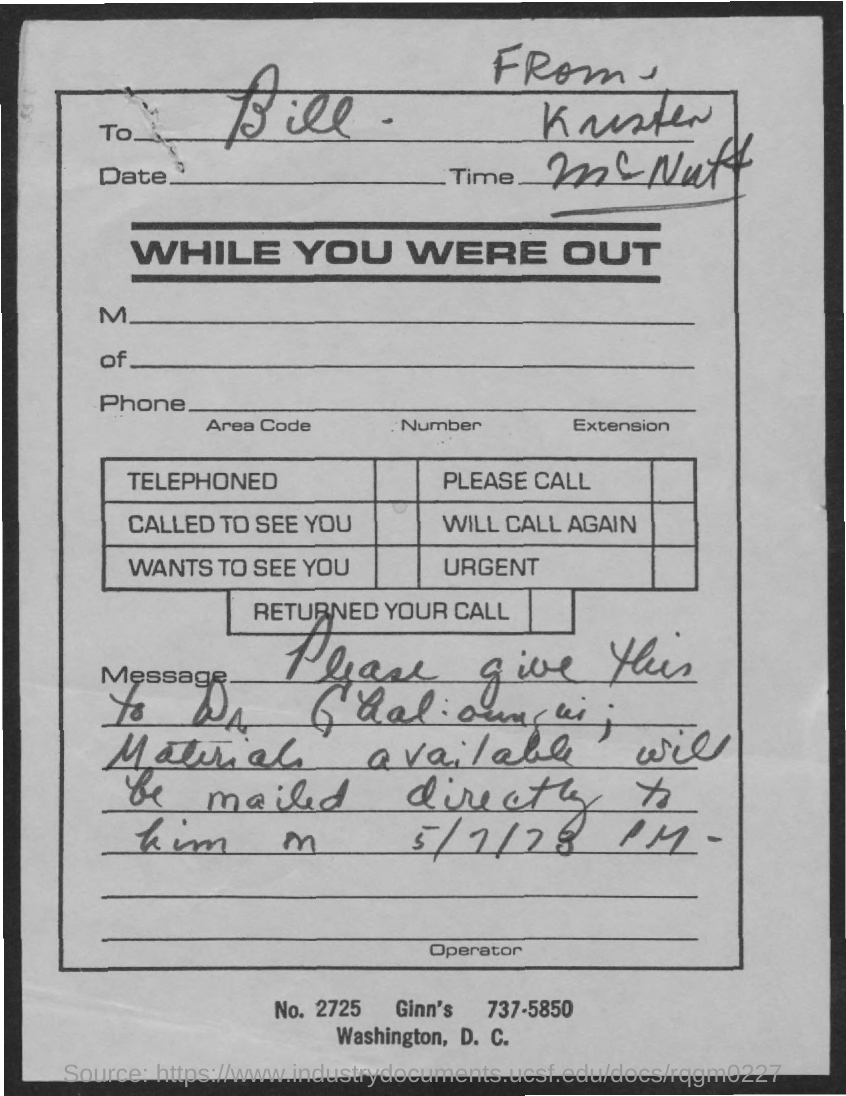Outline some significant characteristics in this image. The letter is addressed to Bill. 